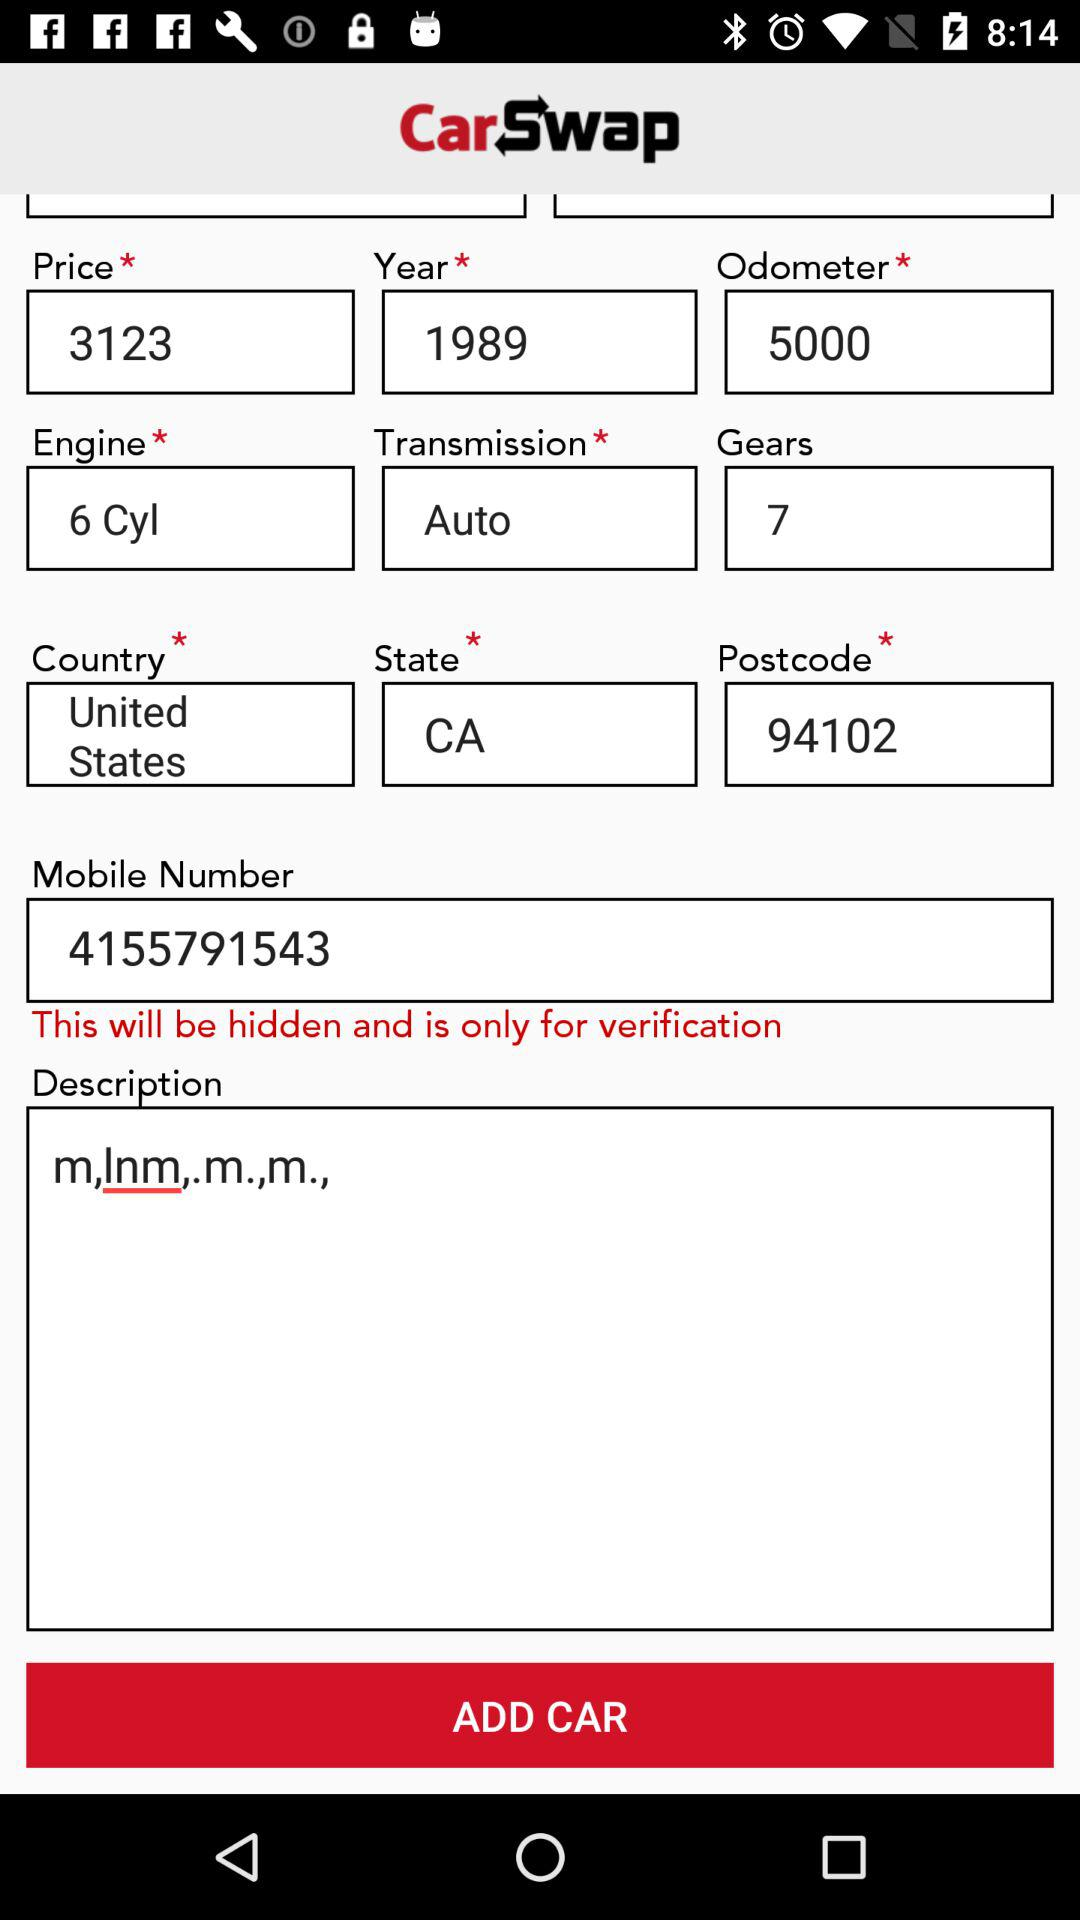What is the transmission? The transmission is "Auto". 